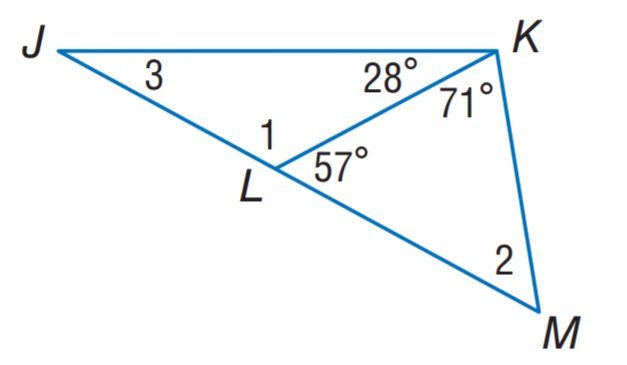Answer the mathemtical geometry problem and directly provide the correct option letter.
Question: Find m \angle 3.
Choices: A: 28 B: 29 C: 52 D: 123 B 